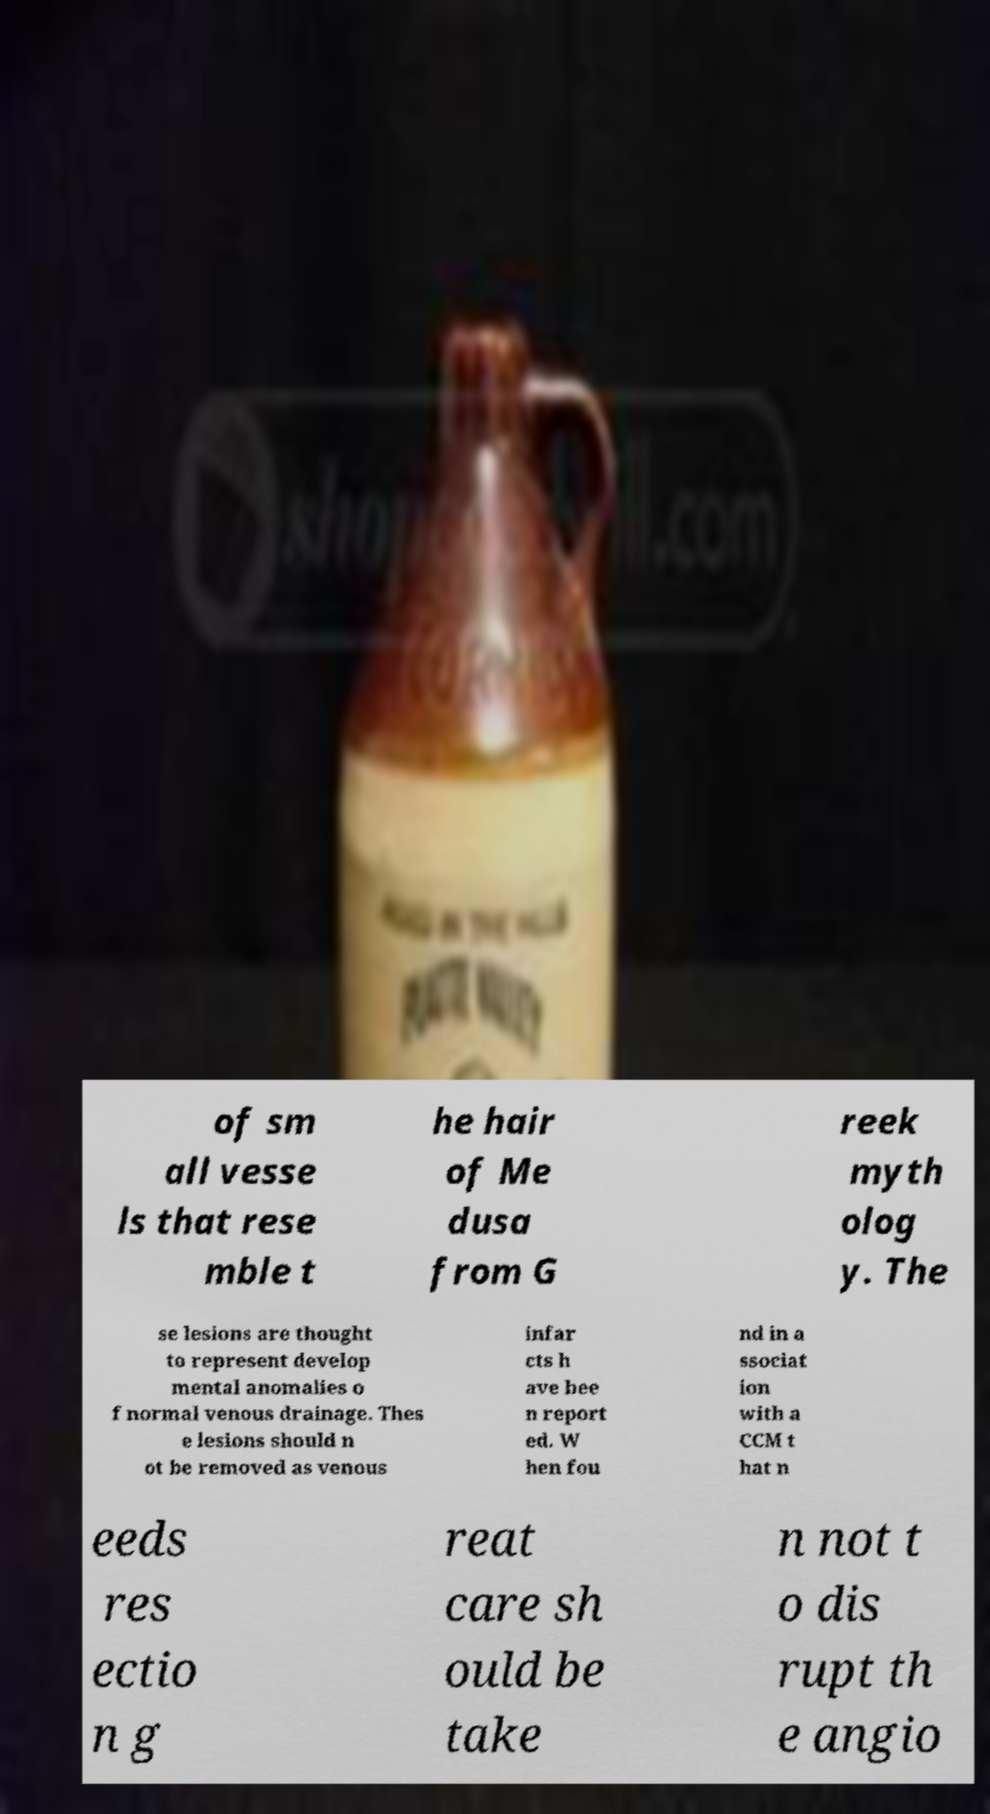For documentation purposes, I need the text within this image transcribed. Could you provide that? of sm all vesse ls that rese mble t he hair of Me dusa from G reek myth olog y. The se lesions are thought to represent develop mental anomalies o f normal venous drainage. Thes e lesions should n ot be removed as venous infar cts h ave bee n report ed. W hen fou nd in a ssociat ion with a CCM t hat n eeds res ectio n g reat care sh ould be take n not t o dis rupt th e angio 